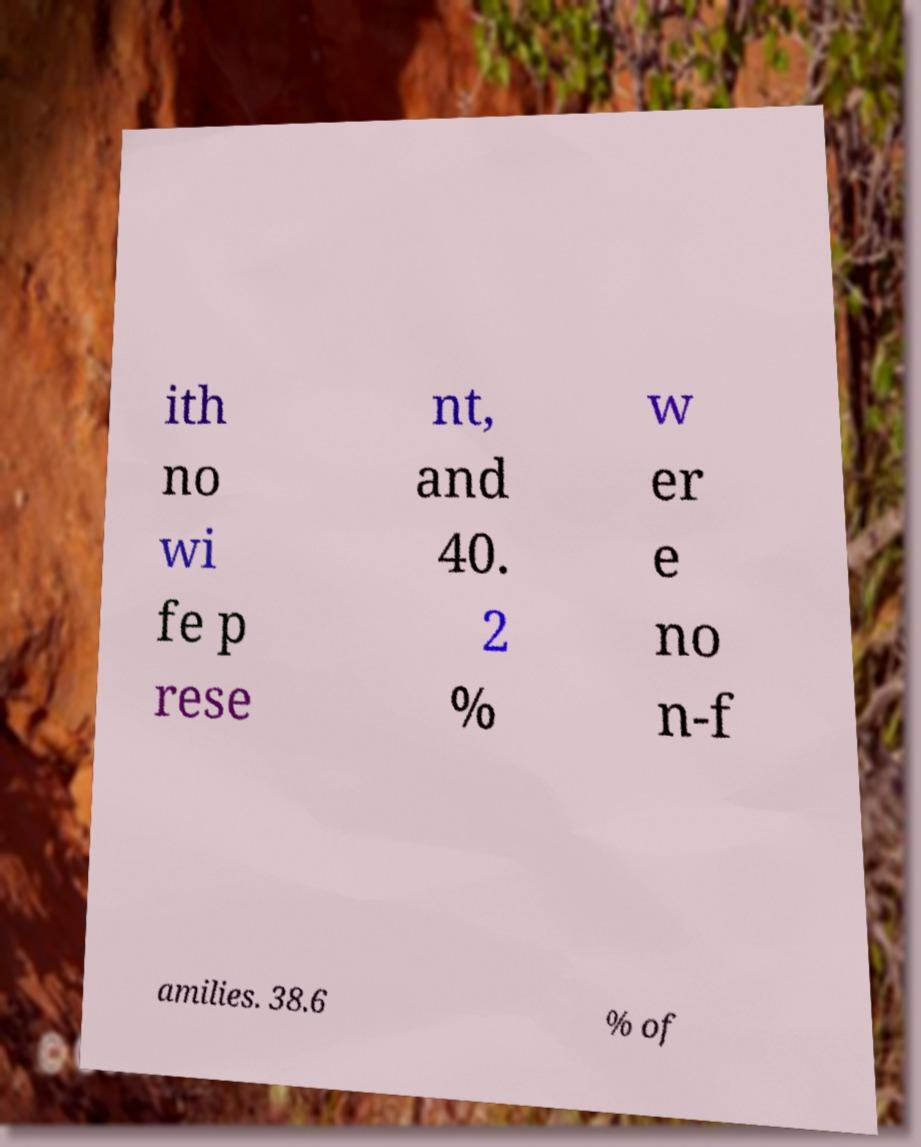For documentation purposes, I need the text within this image transcribed. Could you provide that? ith no wi fe p rese nt, and 40. 2 % w er e no n-f amilies. 38.6 % of 